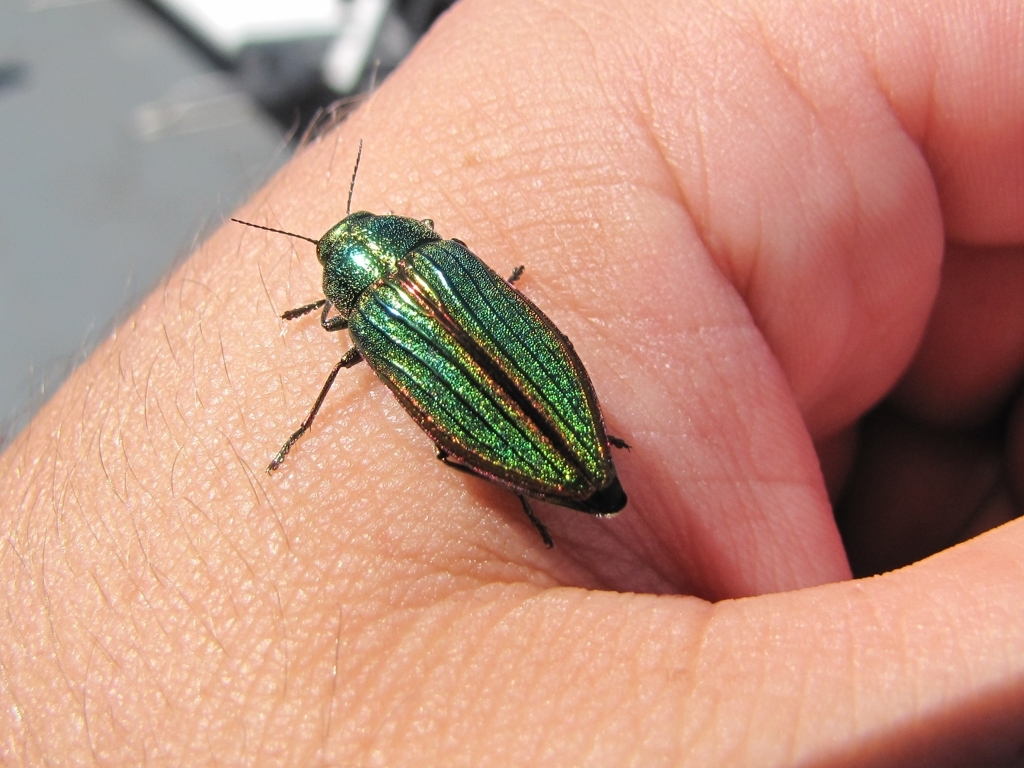How clear are the pattern details on the insect's body?
A. Distorted
B. Very clear
C. Unclear
D. Blurred
Answer with the option's letter from the given choices directly.
 B. 